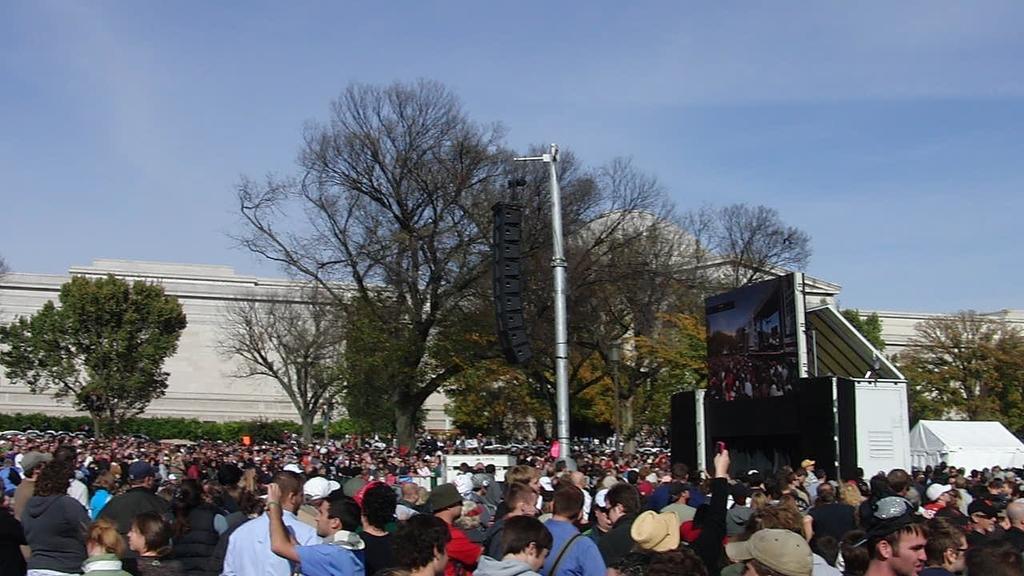How would you summarize this image in a sentence or two? In this picture I can see a number of people on the surface. I can see the screen. I can see the speakers. I can see trees. I can see clouds in the sky. 